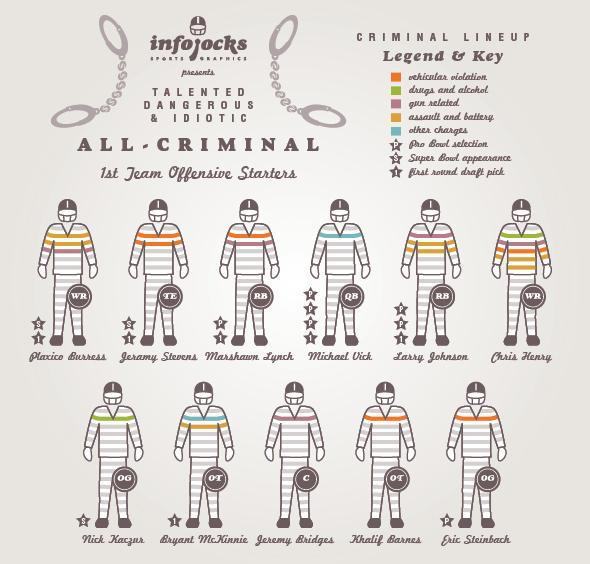Who were marked for Super Bowl appearance and First round draft pick
Answer the question with a short phrase. Plaxico Burress, Jeramy Stevens What was the offence registered against Michael Vick other charges Who all the registered for drug and alcohol related charges Chris Henry, Nick Kaczur What were the offence registered against Marshawn Lynck vehicular violation, gun related Who all were registered only for vehicular violation Jeramy Stevens, Khalid Barnes, Eric Steinback WHo was marked for Pro Bowl Selection three times Michael Vick What was the offence registered against Khalid Barnes vehicular violation 